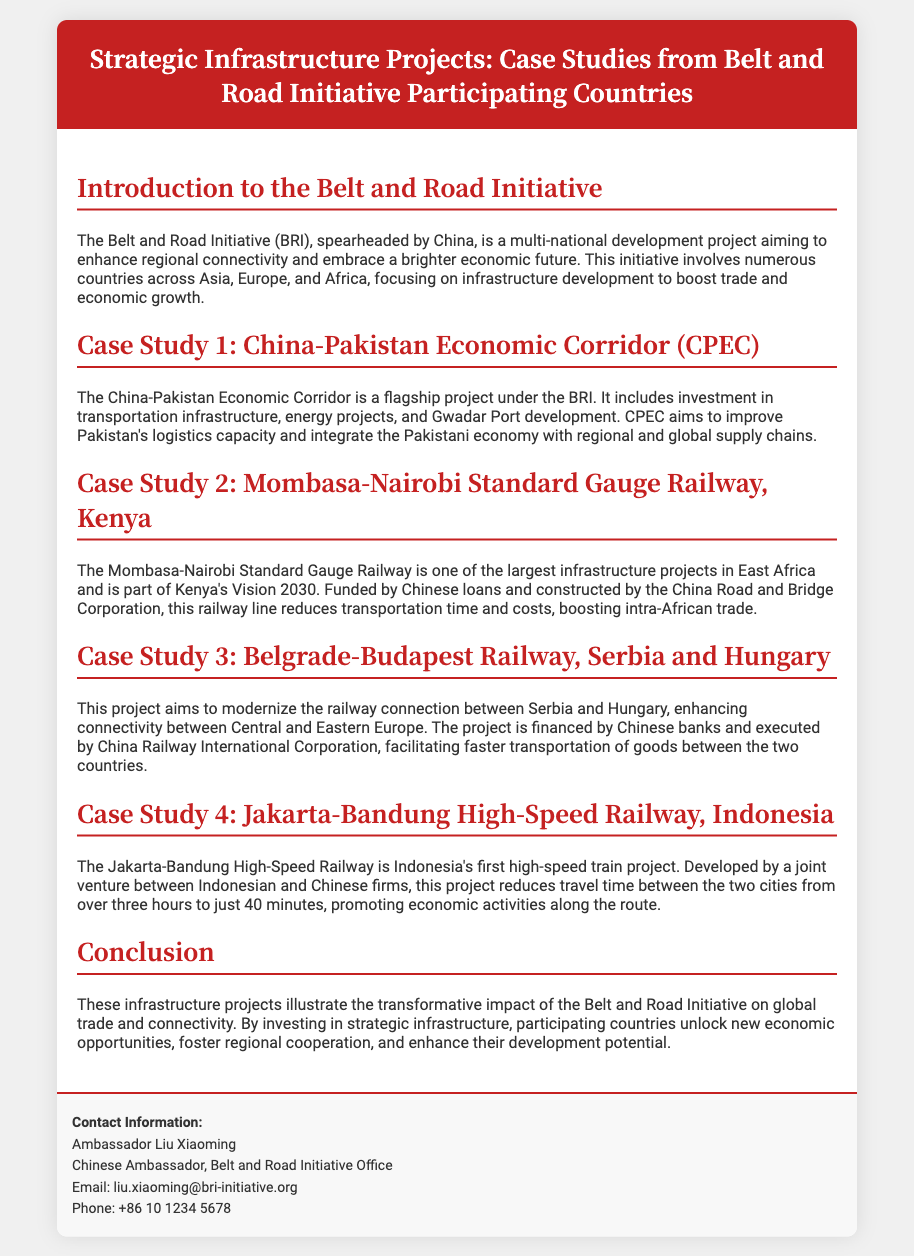What is the title of the document? The title is indicated in the header of the Playbill.
Answer: Strategic Infrastructure Projects: Case Studies from Belt and Road Initiative Participating Countries Who is the contact person for the Belt and Road Initiative? The contact information section specifies the individual's name.
Answer: Ambassador Liu Xiaoming What is the primary aim of the Belt and Road Initiative? The introduction section summarizes the main objective of the initiative.
Answer: Enhance regional connectivity Which country is the China-Pakistan Economic Corridor located in? The case study explicitly mentions the country where CPEC is situated.
Answer: Pakistan What does the Mombasa-Nairobi Standard Gauge Railway project aim to boost? The document states the impact of this railway project in its description.
Answer: Intra-African trade How many case studies are presented in the document? The number of case studies can be counted from the sections listed.
Answer: Four What is the expected travel time reduction for the Jakarta-Bandung High-Speed Railway? The case study provides specific travel time information comparing the old and new durations.
Answer: From over three hours to just 40 minutes Which country collaborates with China on the Jakarta-Bandung project? The case study describes the partnership involved in this particular project.
Answer: Indonesia What type of infrastructure development does the Belt and Road Initiative focus on? The introduction indicates the main focus of the initiative.
Answer: Infrastructure development 